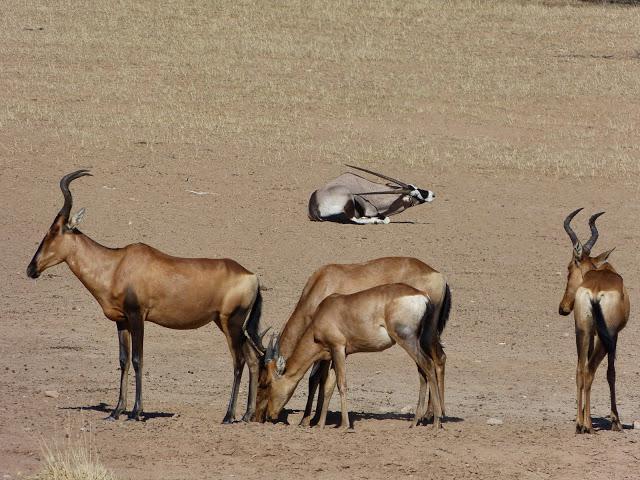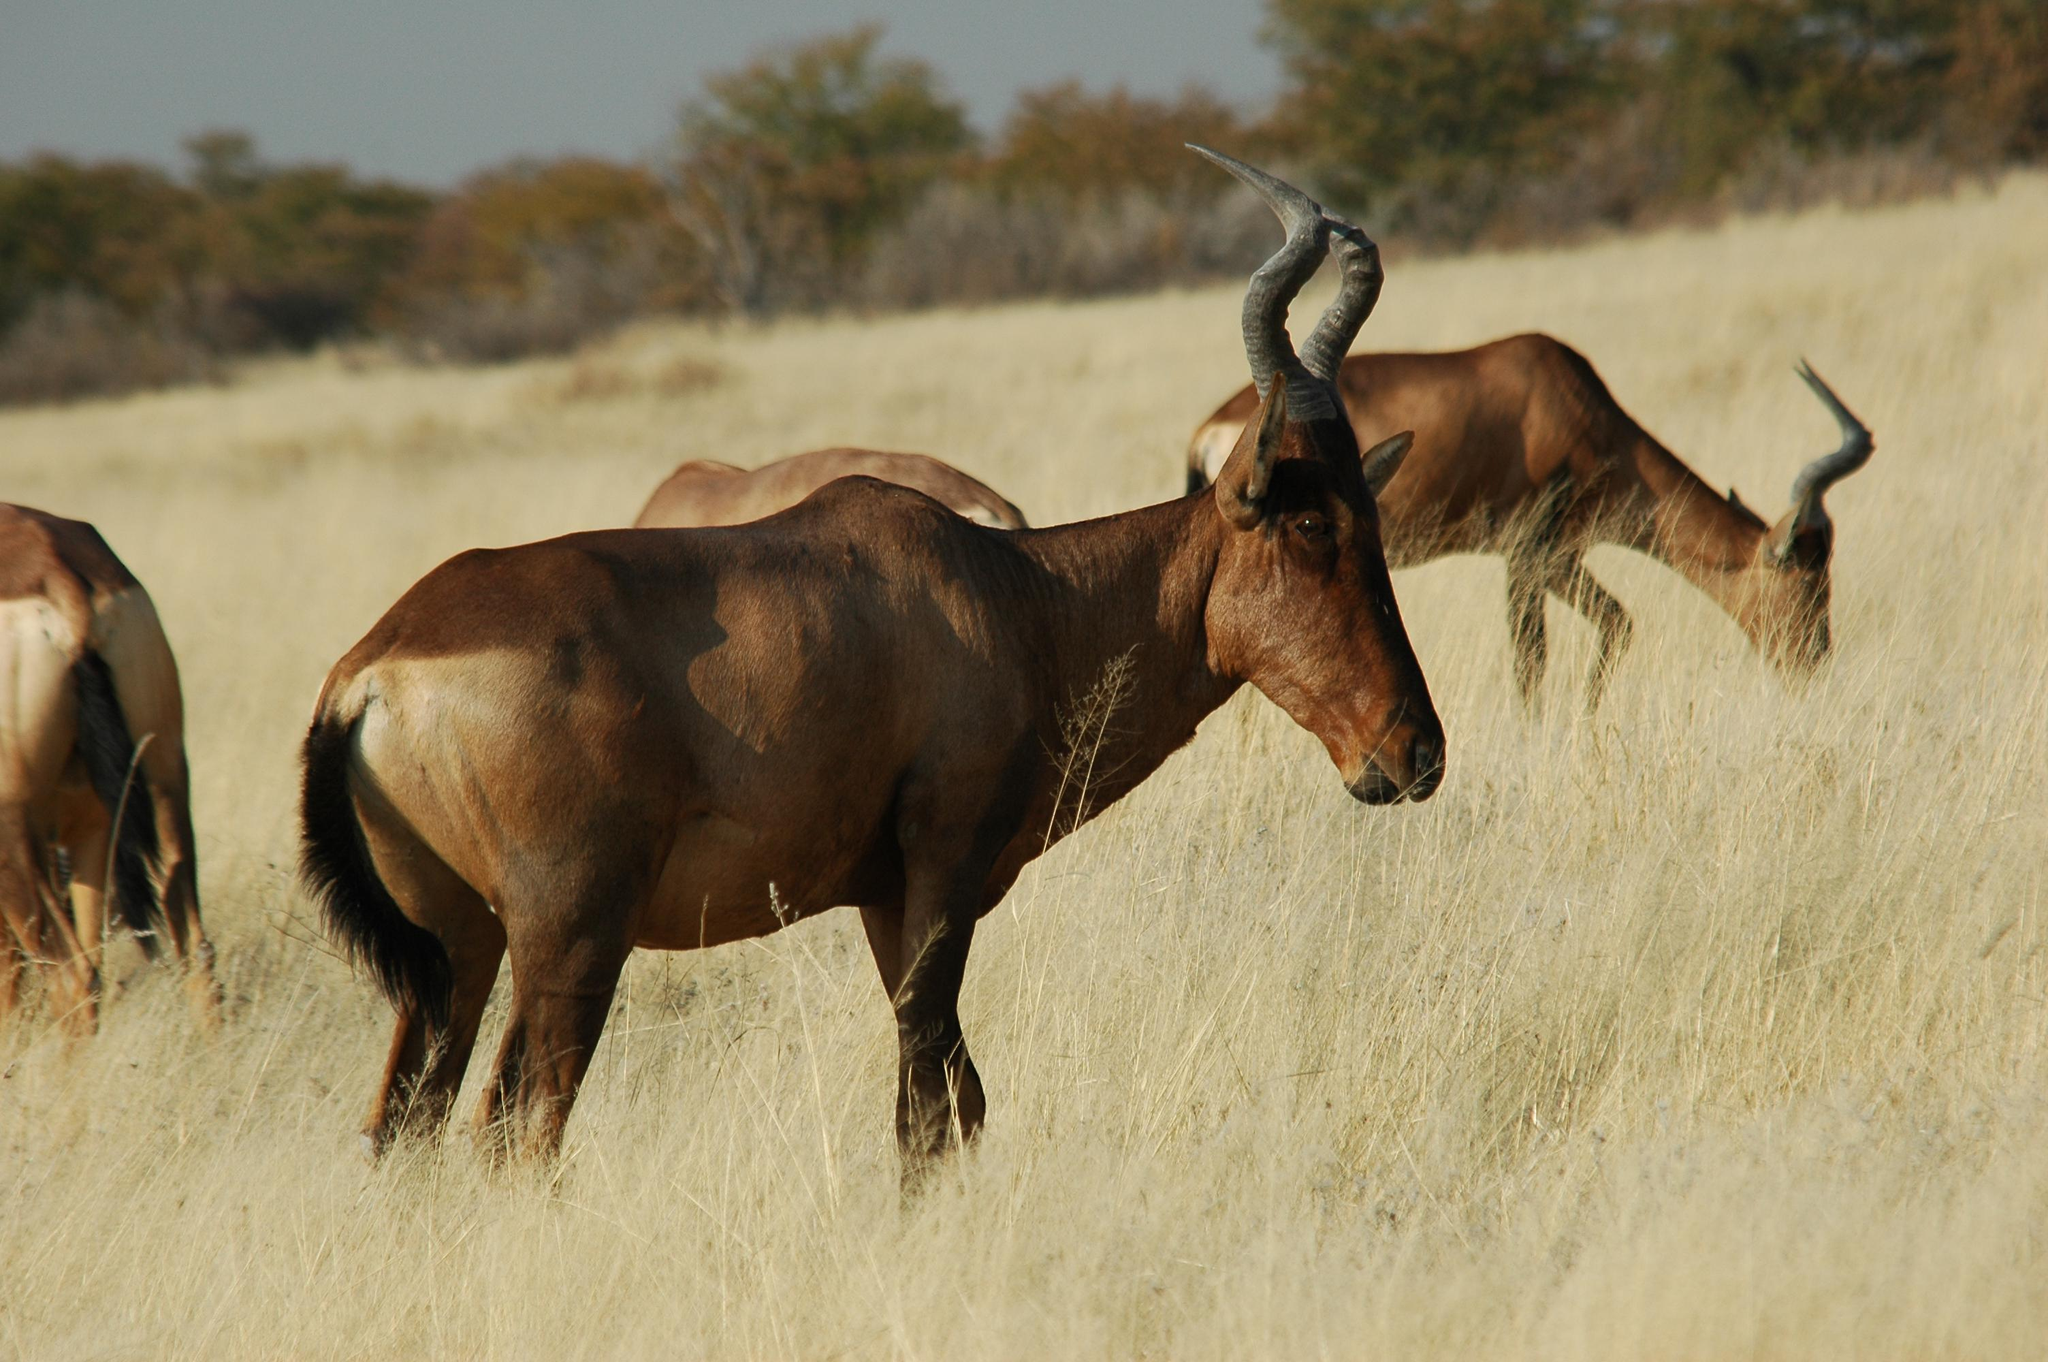The first image is the image on the left, the second image is the image on the right. Given the left and right images, does the statement "One image includes a single adult horned animal, and the other image features a row of horned animals who face the same direction." hold true? Answer yes or no. No. The first image is the image on the left, the second image is the image on the right. Analyze the images presented: Is the assertion "In at least one image there is a single elk walking right." valid? Answer yes or no. No. 